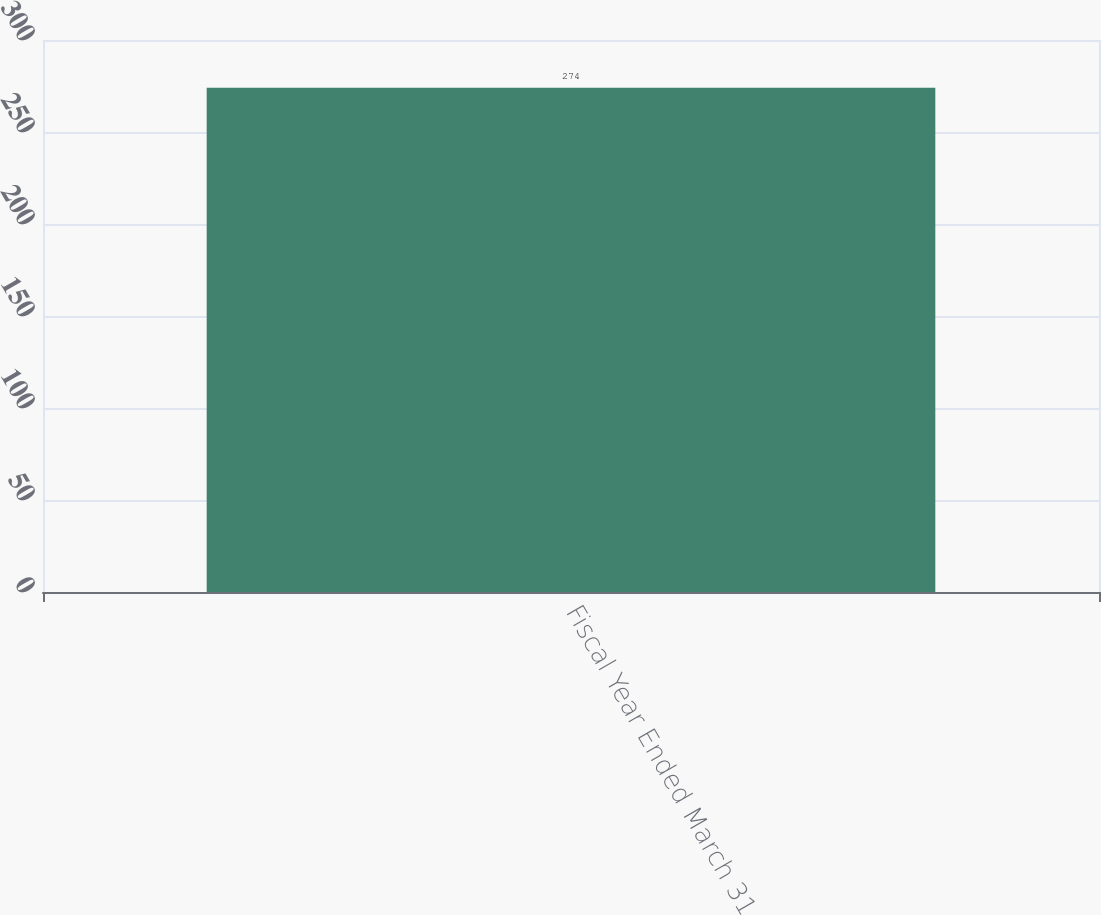<chart> <loc_0><loc_0><loc_500><loc_500><bar_chart><fcel>Fiscal Year Ended March 31<nl><fcel>274<nl></chart> 